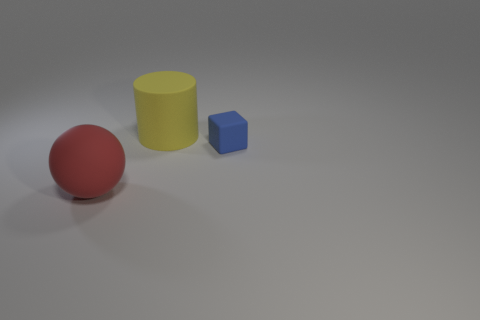Is there a cylinder that has the same size as the red matte object?
Your answer should be very brief. Yes. Is the number of large yellow matte cylinders right of the yellow matte cylinder less than the number of brown rubber cylinders?
Provide a short and direct response. No. Is the number of yellow objects that are in front of the red rubber sphere less than the number of big red objects in front of the tiny block?
Offer a terse response. Yes. What number of cylinders are either large yellow matte things or small rubber objects?
Ensure brevity in your answer.  1. Do the large object that is to the right of the red ball and the large thing in front of the tiny blue matte block have the same material?
Provide a short and direct response. Yes. What shape is the rubber thing that is the same size as the yellow matte cylinder?
Offer a very short reply. Sphere. How many red things are either matte spheres or cylinders?
Provide a succinct answer. 1. Is the shape of the large rubber object that is on the right side of the red rubber thing the same as the matte thing that is in front of the blue matte block?
Your answer should be very brief. No. How many other objects are there of the same material as the small block?
Offer a terse response. 2. There is a large matte object behind the object right of the large yellow rubber cylinder; is there a big red matte thing that is to the left of it?
Offer a terse response. Yes. 